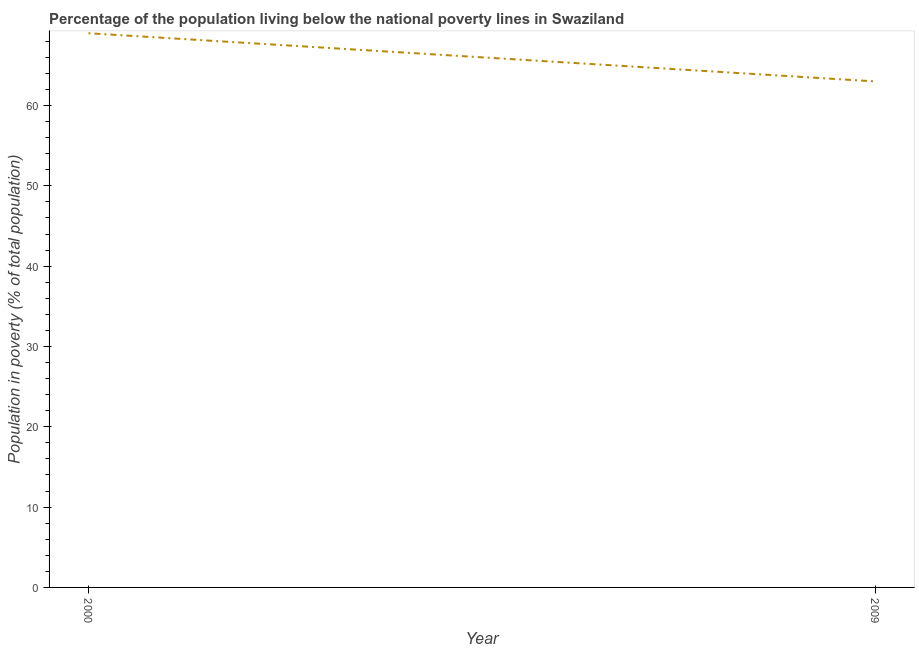What is the percentage of population living below poverty line in 2009?
Make the answer very short. 63. Across all years, what is the maximum percentage of population living below poverty line?
Offer a very short reply. 69. Across all years, what is the minimum percentage of population living below poverty line?
Make the answer very short. 63. In which year was the percentage of population living below poverty line maximum?
Keep it short and to the point. 2000. What is the sum of the percentage of population living below poverty line?
Your response must be concise. 132. What is the difference between the percentage of population living below poverty line in 2000 and 2009?
Offer a very short reply. 6. What is the average percentage of population living below poverty line per year?
Your answer should be compact. 66. What is the ratio of the percentage of population living below poverty line in 2000 to that in 2009?
Offer a very short reply. 1.1. Is the percentage of population living below poverty line in 2000 less than that in 2009?
Offer a very short reply. No. How many lines are there?
Give a very brief answer. 1. How many years are there in the graph?
Ensure brevity in your answer.  2. Does the graph contain any zero values?
Offer a very short reply. No. Does the graph contain grids?
Provide a short and direct response. No. What is the title of the graph?
Provide a short and direct response. Percentage of the population living below the national poverty lines in Swaziland. What is the label or title of the X-axis?
Provide a short and direct response. Year. What is the label or title of the Y-axis?
Offer a terse response. Population in poverty (% of total population). What is the Population in poverty (% of total population) in 2000?
Provide a succinct answer. 69. What is the Population in poverty (% of total population) in 2009?
Offer a terse response. 63. What is the difference between the Population in poverty (% of total population) in 2000 and 2009?
Your answer should be compact. 6. What is the ratio of the Population in poverty (% of total population) in 2000 to that in 2009?
Give a very brief answer. 1.09. 